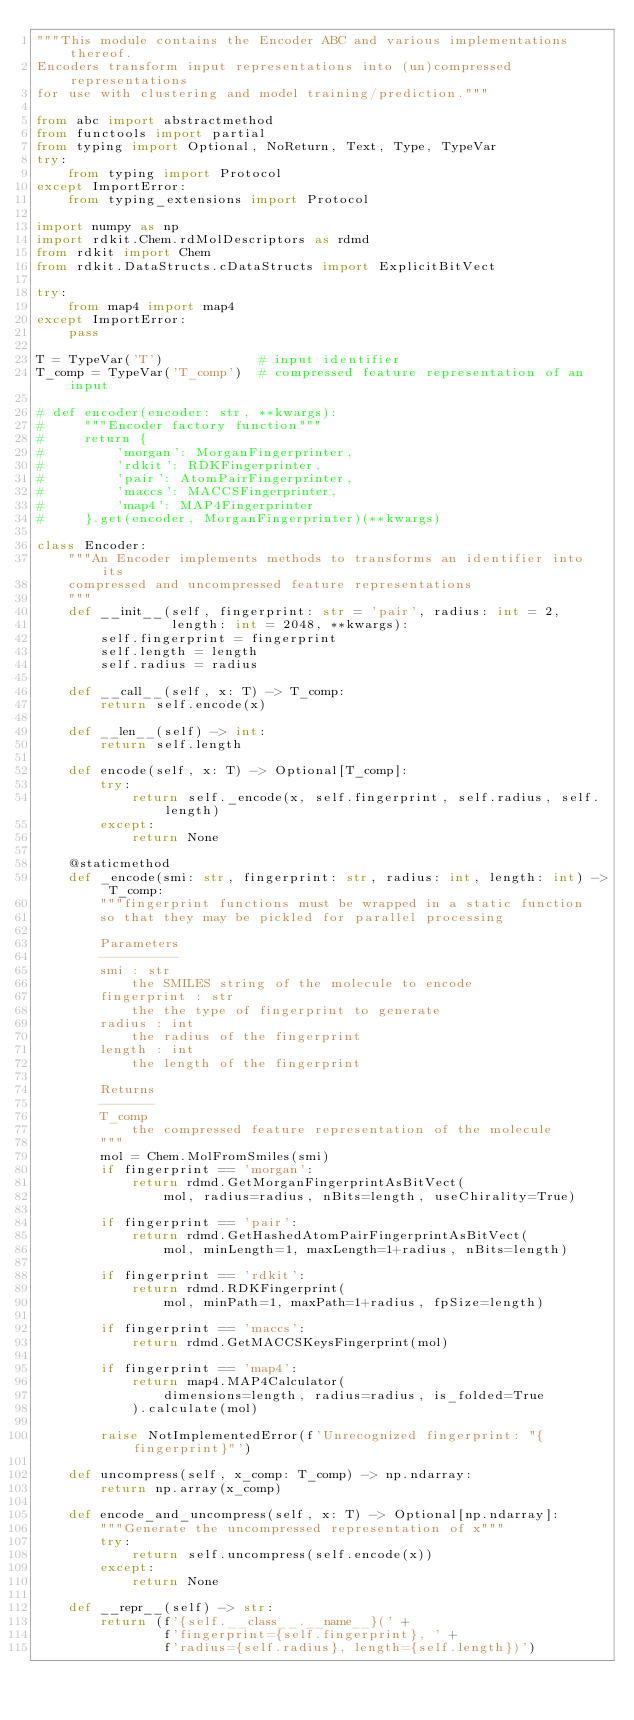<code> <loc_0><loc_0><loc_500><loc_500><_Python_>"""This module contains the Encoder ABC and various implementations thereof.
Encoders transform input representations into (un)compressed representations
for use with clustering and model training/prediction."""

from abc import abstractmethod
from functools import partial
from typing import Optional, NoReturn, Text, Type, TypeVar
try:
    from typing import Protocol
except ImportError:
    from typing_extensions import Protocol

import numpy as np
import rdkit.Chem.rdMolDescriptors as rdmd
from rdkit import Chem
from rdkit.DataStructs.cDataStructs import ExplicitBitVect

try:
    from map4 import map4
except ImportError:
    pass

T = TypeVar('T')            # input identifier
T_comp = TypeVar('T_comp')  # compressed feature representation of an input

# def encoder(encoder: str, **kwargs):
#     """Encoder factory function"""
#     return {
#         'morgan': MorganFingerprinter,
#         'rdkit': RDKFingerprinter,
#         'pair': AtomPairFingerprinter,
#         'maccs': MACCSFingerprinter,
#         'map4': MAP4Fingerprinter
#     }.get(encoder, MorganFingerprinter)(**kwargs)

class Encoder:
    """An Encoder implements methods to transforms an identifier into its
    compressed and uncompressed feature representations
    """
    def __init__(self, fingerprint: str = 'pair', radius: int = 2,
                 length: int = 2048, **kwargs):
        self.fingerprint = fingerprint
        self.length = length
        self.radius = radius

    def __call__(self, x: T) -> T_comp:
        return self.encode(x)

    def __len__(self) -> int:
        return self.length

    def encode(self, x: T) -> Optional[T_comp]:
        try:
            return self._encode(x, self.fingerprint, self.radius, self.length)
        except:
            return None
    
    @staticmethod
    def _encode(smi: str, fingerprint: str, radius: int, length: int) -> T_comp:
        """fingerprint functions must be wrapped in a static function
        so that they may be pickled for parallel processing
        
        Parameters
        ----------
        smi : str
            the SMILES string of the molecule to encode
        fingerprint : str
            the the type of fingerprint to generate
        radius : int
            the radius of the fingerprint
        length : int
            the length of the fingerprint
        
        Returns
        -------
        T_comp
            the compressed feature representation of the molecule
        """
        mol = Chem.MolFromSmiles(smi)
        if fingerprint == 'morgan':
            return rdmd.GetMorganFingerprintAsBitVect(
                mol, radius=radius, nBits=length, useChirality=True)

        if fingerprint == 'pair':
            return rdmd.GetHashedAtomPairFingerprintAsBitVect(
                mol, minLength=1, maxLength=1+radius, nBits=length)
        
        if fingerprint == 'rdkit':
            return rdmd.RDKFingerprint(
                mol, minPath=1, maxPath=1+radius, fpSize=length)
        
        if fingerprint == 'maccs':
            return rdmd.GetMACCSKeysFingerprint(mol)

        if fingerprint == 'map4':
            return map4.MAP4Calculator(
                dimensions=length, radius=radius, is_folded=True
            ).calculate(mol)

        raise NotImplementedError(f'Unrecognized fingerprint: "{fingerprint}"')

    def uncompress(self, x_comp: T_comp) -> np.ndarray:
        return np.array(x_comp)

    def encode_and_uncompress(self, x: T) -> Optional[np.ndarray]:
        """Generate the uncompressed representation of x"""
        try:
            return self.uncompress(self.encode(x))
        except:
            return None

    def __repr__(self) -> str:
        return (f'{self.__class__.__name__}(' + 
                f'fingerprint={self.fingerprint}, ' +
                f'radius={self.radius}, length={self.length})')
</code> 